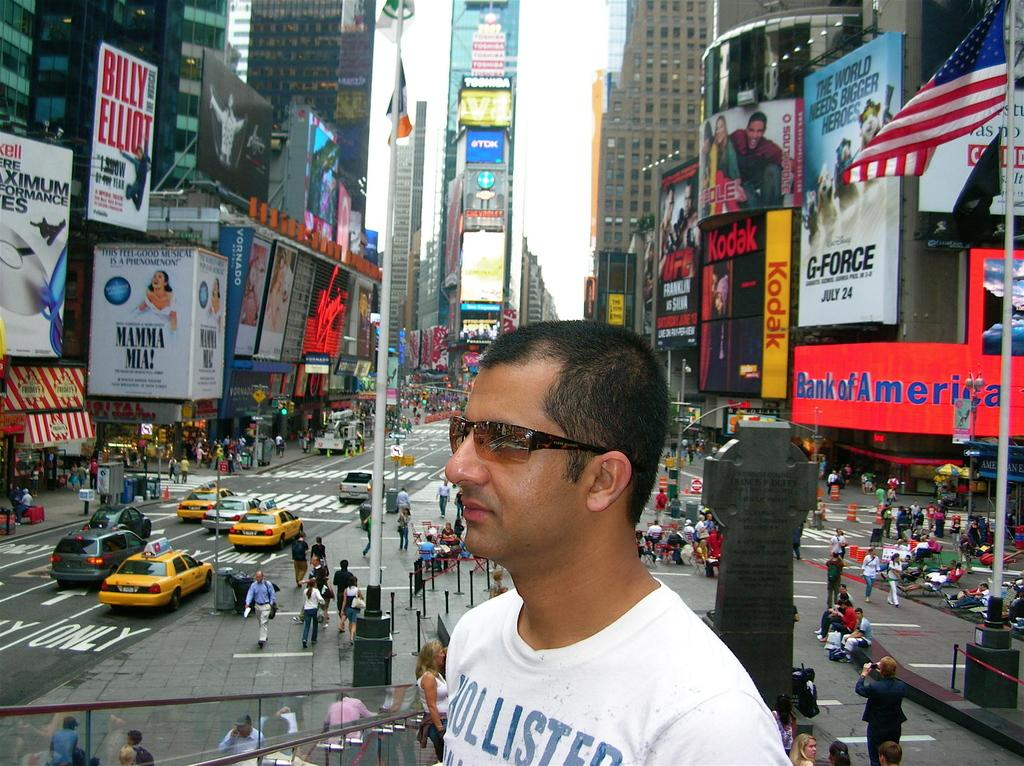<image>
Summarize the visual content of the image. Bank of America can be seen to the right of the man in white. 